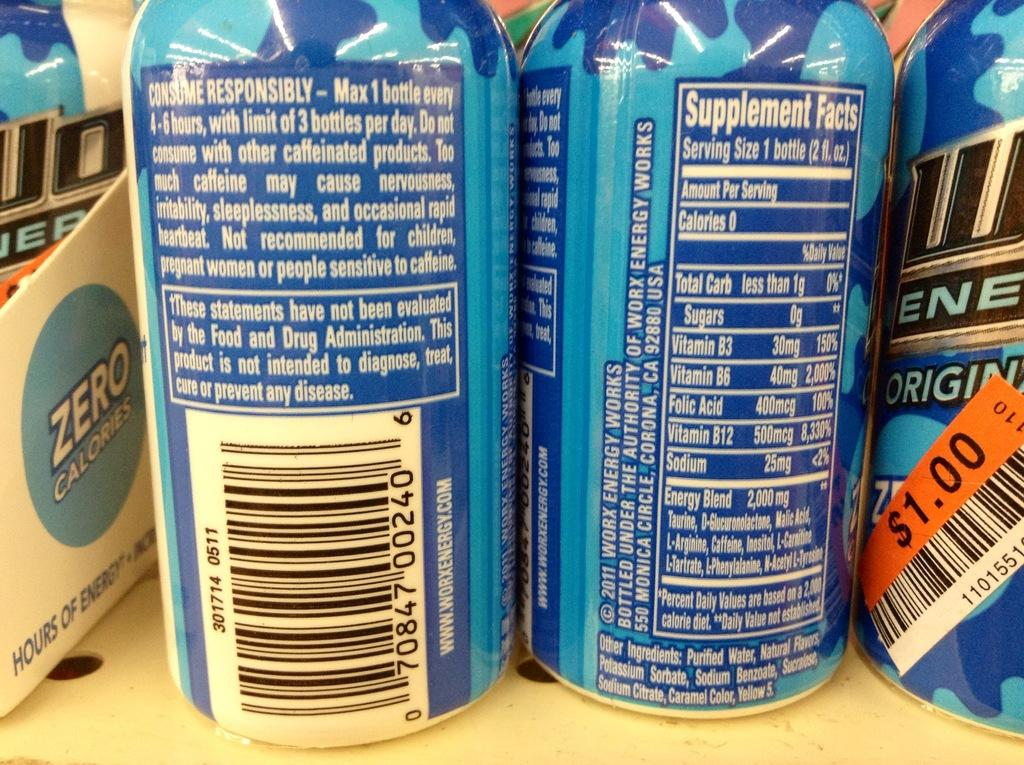Provide a one-sentence caption for the provided image. The back of a blue can says consume responsibly. 